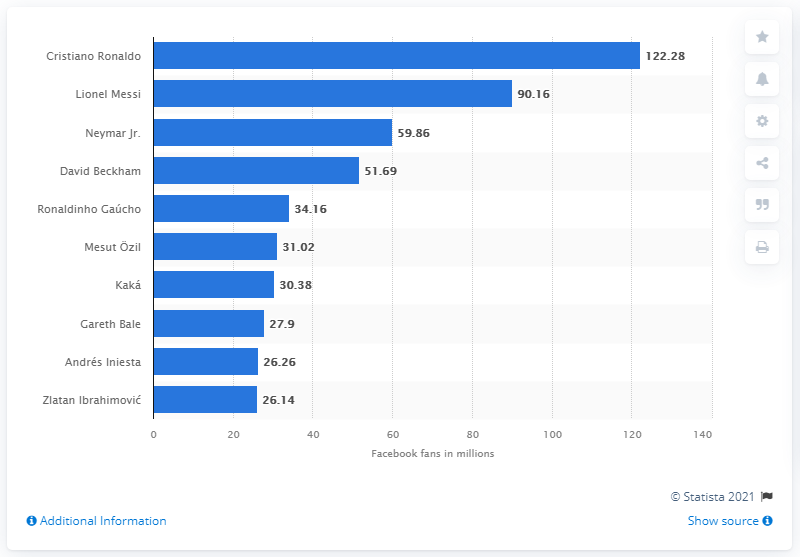Point out several critical features in this image. The most-followed soccer player on Facebook is Cristiano Ronaldo. 